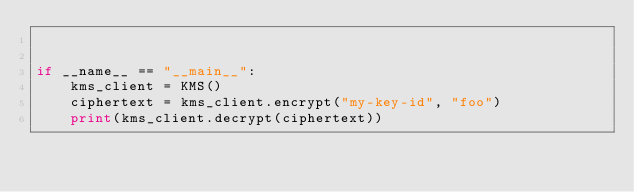<code> <loc_0><loc_0><loc_500><loc_500><_Python_>

if __name__ == "__main__":
    kms_client = KMS()
    ciphertext = kms_client.encrypt("my-key-id", "foo")
    print(kms_client.decrypt(ciphertext))
</code> 